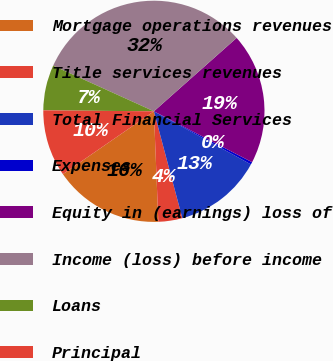<chart> <loc_0><loc_0><loc_500><loc_500><pie_chart><fcel>Mortgage operations revenues<fcel>Title services revenues<fcel>Total Financial Services<fcel>Expenses<fcel>Equity in (earnings) loss of<fcel>Income (loss) before income<fcel>Loans<fcel>Principal<nl><fcel>16.02%<fcel>3.5%<fcel>12.89%<fcel>0.36%<fcel>19.16%<fcel>31.68%<fcel>6.63%<fcel>9.76%<nl></chart> 